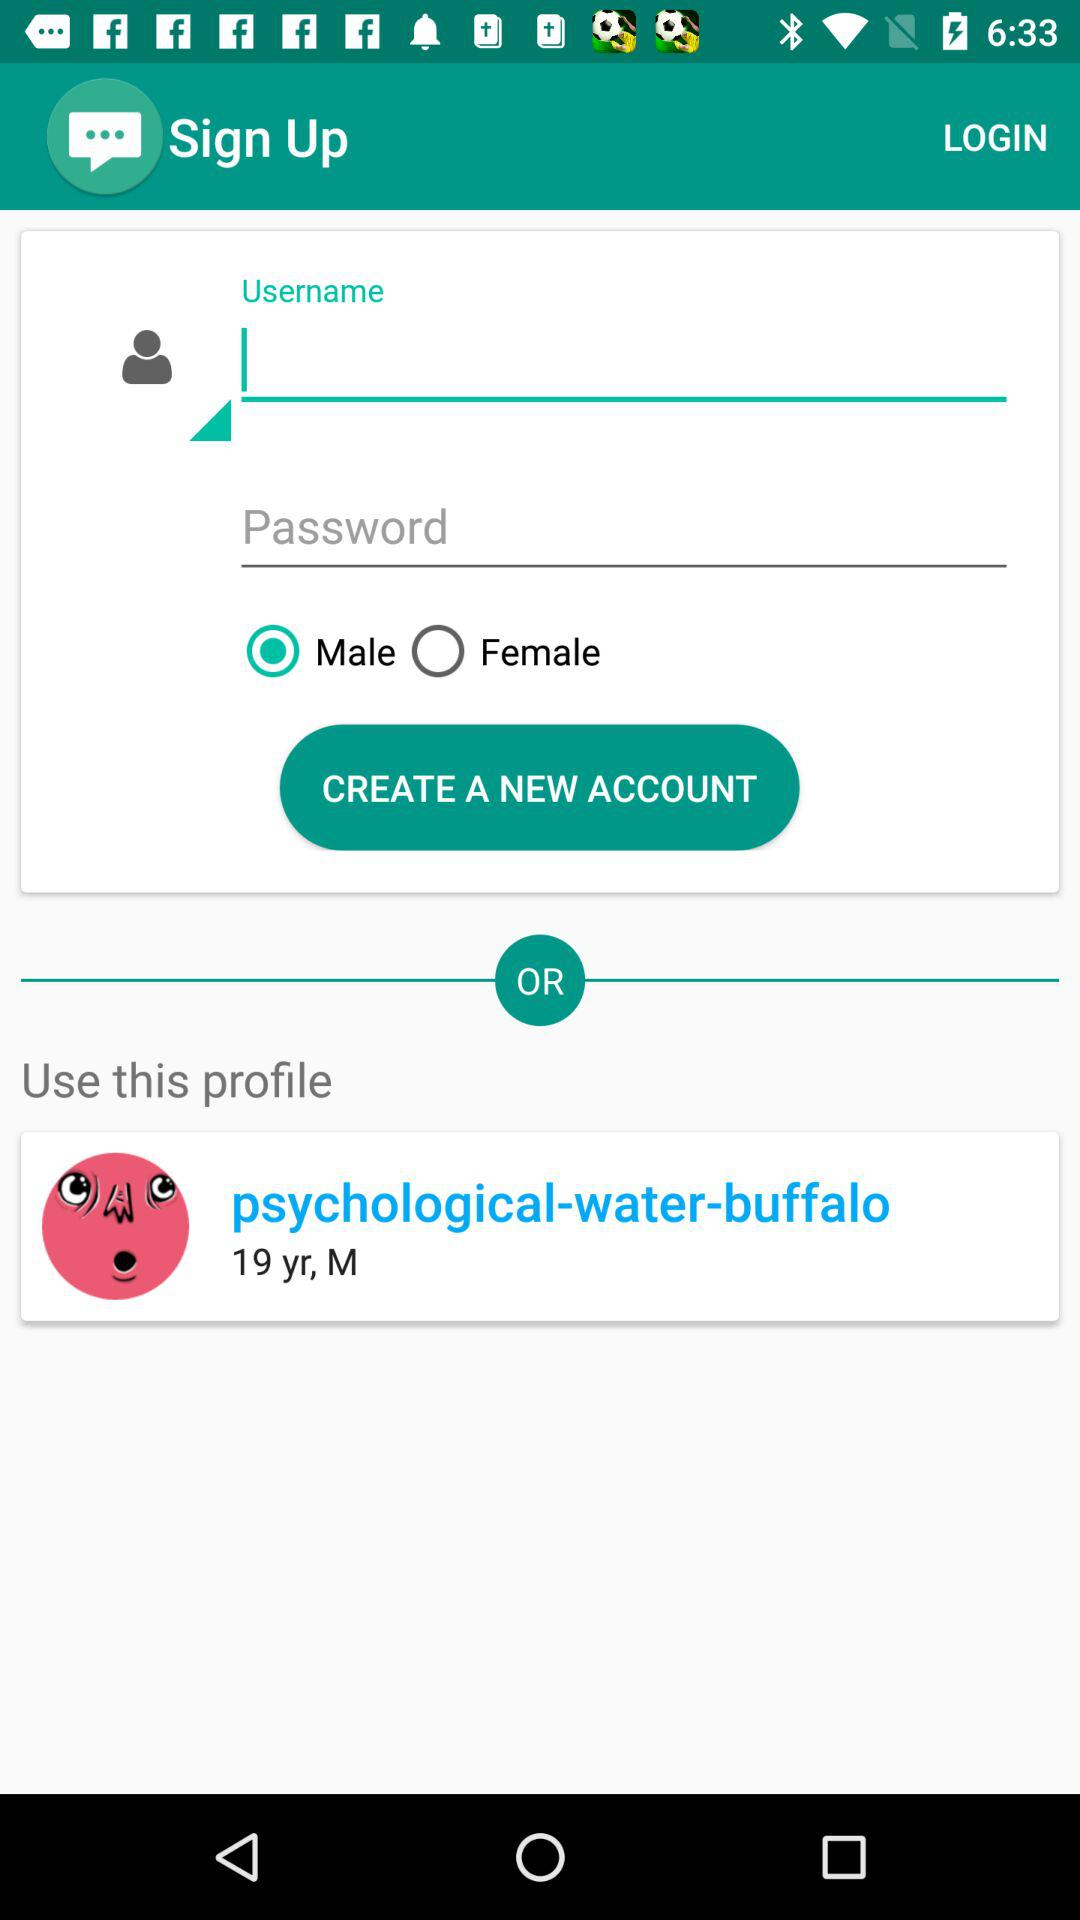What is the profile name? The profile name is "psychological-water-buffalo". 